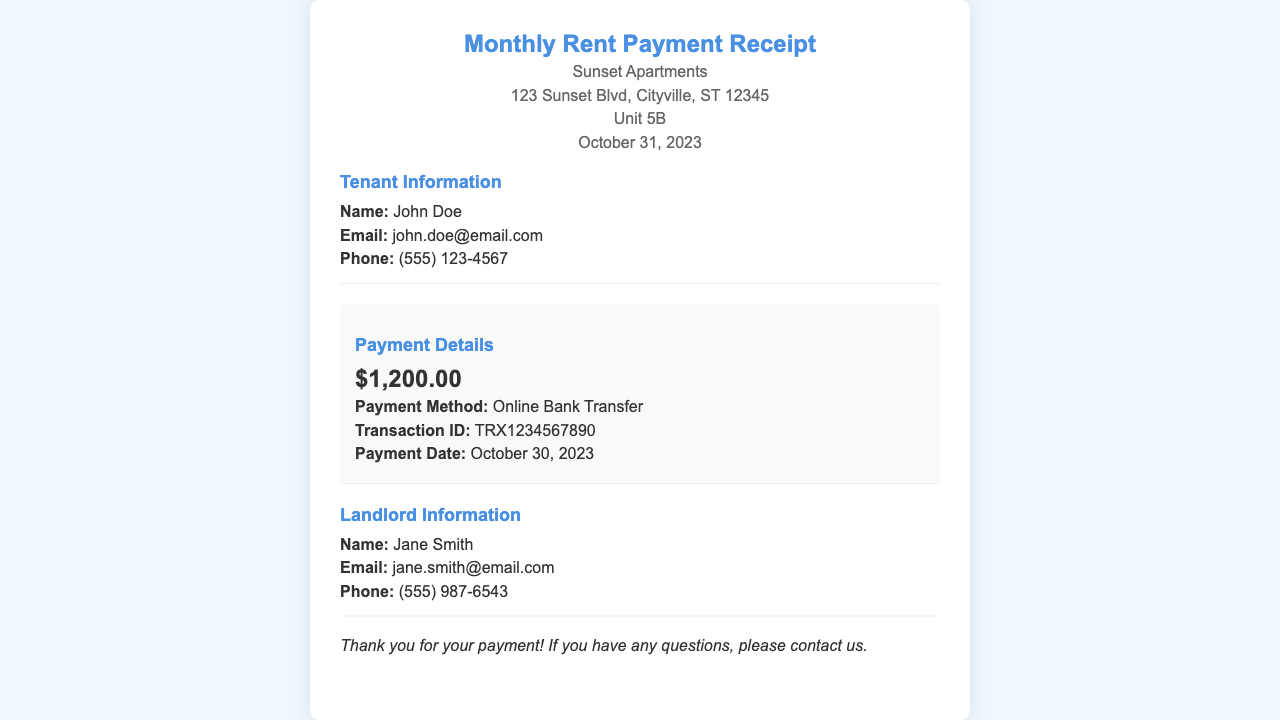What is the name of the tenant? The tenant's name is listed in the document under Tenant Information.
Answer: John Doe What is the total rent amount? The total amount is displayed in the Payment Details section.
Answer: $1,200.00 What was the payment method used? The payment method is specified in the Payment Details section.
Answer: Online Bank Transfer When was the payment date? The payment date is mentioned in the Payment Details section.
Answer: October 30, 2023 What is the transaction ID for this payment? The transaction ID can be found in the Payment Details section.
Answer: TRX1234567890 Who is the landlord's contact email? The landlord's email is provided under Landlord Information.
Answer: jane.smith@email.com Which unit is this receipt for? The unit number is clearly stated in the receipt title and tenant information.
Answer: Unit 5B What is the address of the apartment complex? The address of Sunset Apartments is detailed in the header of the receipt.
Answer: 123 Sunset Blvd, Cityville, ST 12345 